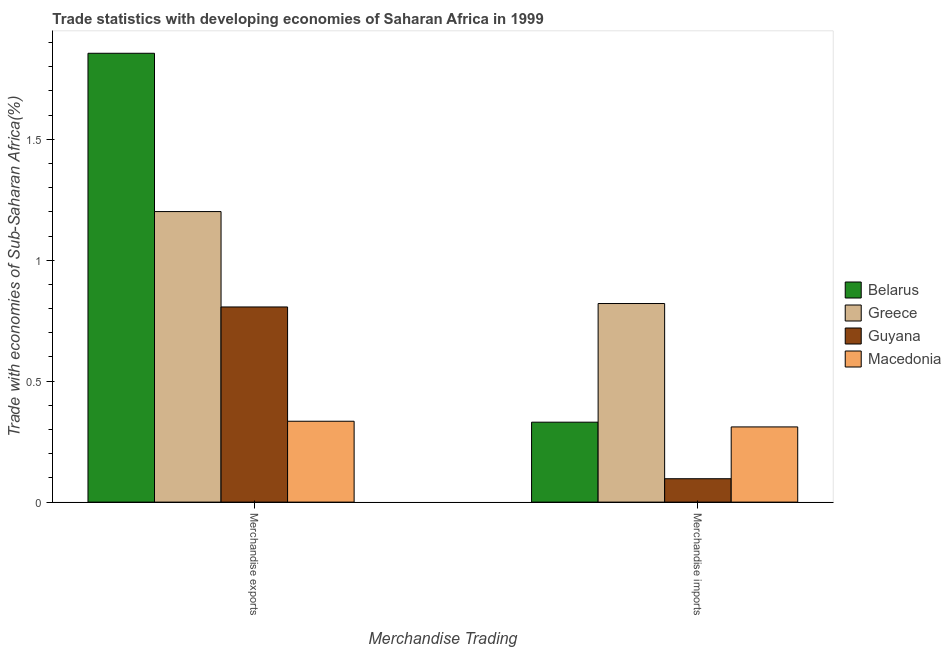How many groups of bars are there?
Your answer should be compact. 2. How many bars are there on the 2nd tick from the left?
Your answer should be very brief. 4. What is the merchandise exports in Belarus?
Offer a terse response. 1.86. Across all countries, what is the maximum merchandise imports?
Provide a short and direct response. 0.82. Across all countries, what is the minimum merchandise exports?
Your answer should be compact. 0.33. In which country was the merchandise exports maximum?
Provide a succinct answer. Belarus. In which country was the merchandise imports minimum?
Provide a short and direct response. Guyana. What is the total merchandise imports in the graph?
Your answer should be very brief. 1.56. What is the difference between the merchandise exports in Macedonia and that in Guyana?
Offer a terse response. -0.47. What is the difference between the merchandise imports in Guyana and the merchandise exports in Greece?
Provide a succinct answer. -1.1. What is the average merchandise imports per country?
Your answer should be very brief. 0.39. What is the difference between the merchandise imports and merchandise exports in Guyana?
Provide a short and direct response. -0.71. What is the ratio of the merchandise exports in Belarus to that in Macedonia?
Provide a succinct answer. 5.55. What does the 2nd bar from the left in Merchandise exports represents?
Your answer should be compact. Greece. What does the 1st bar from the right in Merchandise imports represents?
Make the answer very short. Macedonia. How many countries are there in the graph?
Give a very brief answer. 4. What is the difference between two consecutive major ticks on the Y-axis?
Ensure brevity in your answer.  0.5. Are the values on the major ticks of Y-axis written in scientific E-notation?
Your response must be concise. No. Does the graph contain any zero values?
Provide a short and direct response. No. How many legend labels are there?
Make the answer very short. 4. What is the title of the graph?
Give a very brief answer. Trade statistics with developing economies of Saharan Africa in 1999. Does "Nigeria" appear as one of the legend labels in the graph?
Ensure brevity in your answer.  No. What is the label or title of the X-axis?
Keep it short and to the point. Merchandise Trading. What is the label or title of the Y-axis?
Give a very brief answer. Trade with economies of Sub-Saharan Africa(%). What is the Trade with economies of Sub-Saharan Africa(%) of Belarus in Merchandise exports?
Your response must be concise. 1.86. What is the Trade with economies of Sub-Saharan Africa(%) in Greece in Merchandise exports?
Provide a short and direct response. 1.2. What is the Trade with economies of Sub-Saharan Africa(%) in Guyana in Merchandise exports?
Offer a very short reply. 0.81. What is the Trade with economies of Sub-Saharan Africa(%) of Macedonia in Merchandise exports?
Offer a very short reply. 0.33. What is the Trade with economies of Sub-Saharan Africa(%) of Belarus in Merchandise imports?
Keep it short and to the point. 0.33. What is the Trade with economies of Sub-Saharan Africa(%) in Greece in Merchandise imports?
Make the answer very short. 0.82. What is the Trade with economies of Sub-Saharan Africa(%) of Guyana in Merchandise imports?
Your answer should be compact. 0.1. What is the Trade with economies of Sub-Saharan Africa(%) of Macedonia in Merchandise imports?
Provide a short and direct response. 0.31. Across all Merchandise Trading, what is the maximum Trade with economies of Sub-Saharan Africa(%) in Belarus?
Make the answer very short. 1.86. Across all Merchandise Trading, what is the maximum Trade with economies of Sub-Saharan Africa(%) in Greece?
Offer a very short reply. 1.2. Across all Merchandise Trading, what is the maximum Trade with economies of Sub-Saharan Africa(%) in Guyana?
Provide a succinct answer. 0.81. Across all Merchandise Trading, what is the maximum Trade with economies of Sub-Saharan Africa(%) in Macedonia?
Provide a succinct answer. 0.33. Across all Merchandise Trading, what is the minimum Trade with economies of Sub-Saharan Africa(%) in Belarus?
Keep it short and to the point. 0.33. Across all Merchandise Trading, what is the minimum Trade with economies of Sub-Saharan Africa(%) of Greece?
Make the answer very short. 0.82. Across all Merchandise Trading, what is the minimum Trade with economies of Sub-Saharan Africa(%) of Guyana?
Your response must be concise. 0.1. Across all Merchandise Trading, what is the minimum Trade with economies of Sub-Saharan Africa(%) of Macedonia?
Your response must be concise. 0.31. What is the total Trade with economies of Sub-Saharan Africa(%) in Belarus in the graph?
Ensure brevity in your answer.  2.19. What is the total Trade with economies of Sub-Saharan Africa(%) in Greece in the graph?
Your response must be concise. 2.02. What is the total Trade with economies of Sub-Saharan Africa(%) of Guyana in the graph?
Make the answer very short. 0.9. What is the total Trade with economies of Sub-Saharan Africa(%) in Macedonia in the graph?
Provide a succinct answer. 0.65. What is the difference between the Trade with economies of Sub-Saharan Africa(%) in Belarus in Merchandise exports and that in Merchandise imports?
Give a very brief answer. 1.53. What is the difference between the Trade with economies of Sub-Saharan Africa(%) in Greece in Merchandise exports and that in Merchandise imports?
Your answer should be very brief. 0.38. What is the difference between the Trade with economies of Sub-Saharan Africa(%) of Guyana in Merchandise exports and that in Merchandise imports?
Your answer should be very brief. 0.71. What is the difference between the Trade with economies of Sub-Saharan Africa(%) in Macedonia in Merchandise exports and that in Merchandise imports?
Provide a short and direct response. 0.02. What is the difference between the Trade with economies of Sub-Saharan Africa(%) of Belarus in Merchandise exports and the Trade with economies of Sub-Saharan Africa(%) of Greece in Merchandise imports?
Offer a very short reply. 1.03. What is the difference between the Trade with economies of Sub-Saharan Africa(%) of Belarus in Merchandise exports and the Trade with economies of Sub-Saharan Africa(%) of Guyana in Merchandise imports?
Ensure brevity in your answer.  1.76. What is the difference between the Trade with economies of Sub-Saharan Africa(%) in Belarus in Merchandise exports and the Trade with economies of Sub-Saharan Africa(%) in Macedonia in Merchandise imports?
Your answer should be compact. 1.54. What is the difference between the Trade with economies of Sub-Saharan Africa(%) of Greece in Merchandise exports and the Trade with economies of Sub-Saharan Africa(%) of Guyana in Merchandise imports?
Offer a terse response. 1.1. What is the difference between the Trade with economies of Sub-Saharan Africa(%) of Greece in Merchandise exports and the Trade with economies of Sub-Saharan Africa(%) of Macedonia in Merchandise imports?
Provide a short and direct response. 0.89. What is the difference between the Trade with economies of Sub-Saharan Africa(%) of Guyana in Merchandise exports and the Trade with economies of Sub-Saharan Africa(%) of Macedonia in Merchandise imports?
Your response must be concise. 0.5. What is the average Trade with economies of Sub-Saharan Africa(%) of Belarus per Merchandise Trading?
Make the answer very short. 1.09. What is the average Trade with economies of Sub-Saharan Africa(%) in Greece per Merchandise Trading?
Offer a terse response. 1.01. What is the average Trade with economies of Sub-Saharan Africa(%) of Guyana per Merchandise Trading?
Your response must be concise. 0.45. What is the average Trade with economies of Sub-Saharan Africa(%) of Macedonia per Merchandise Trading?
Keep it short and to the point. 0.32. What is the difference between the Trade with economies of Sub-Saharan Africa(%) in Belarus and Trade with economies of Sub-Saharan Africa(%) in Greece in Merchandise exports?
Provide a short and direct response. 0.65. What is the difference between the Trade with economies of Sub-Saharan Africa(%) of Belarus and Trade with economies of Sub-Saharan Africa(%) of Guyana in Merchandise exports?
Keep it short and to the point. 1.05. What is the difference between the Trade with economies of Sub-Saharan Africa(%) of Belarus and Trade with economies of Sub-Saharan Africa(%) of Macedonia in Merchandise exports?
Provide a short and direct response. 1.52. What is the difference between the Trade with economies of Sub-Saharan Africa(%) in Greece and Trade with economies of Sub-Saharan Africa(%) in Guyana in Merchandise exports?
Your answer should be very brief. 0.39. What is the difference between the Trade with economies of Sub-Saharan Africa(%) in Greece and Trade with economies of Sub-Saharan Africa(%) in Macedonia in Merchandise exports?
Ensure brevity in your answer.  0.87. What is the difference between the Trade with economies of Sub-Saharan Africa(%) in Guyana and Trade with economies of Sub-Saharan Africa(%) in Macedonia in Merchandise exports?
Your answer should be very brief. 0.47. What is the difference between the Trade with economies of Sub-Saharan Africa(%) of Belarus and Trade with economies of Sub-Saharan Africa(%) of Greece in Merchandise imports?
Provide a succinct answer. -0.49. What is the difference between the Trade with economies of Sub-Saharan Africa(%) of Belarus and Trade with economies of Sub-Saharan Africa(%) of Guyana in Merchandise imports?
Your answer should be compact. 0.23. What is the difference between the Trade with economies of Sub-Saharan Africa(%) in Belarus and Trade with economies of Sub-Saharan Africa(%) in Macedonia in Merchandise imports?
Offer a terse response. 0.02. What is the difference between the Trade with economies of Sub-Saharan Africa(%) of Greece and Trade with economies of Sub-Saharan Africa(%) of Guyana in Merchandise imports?
Keep it short and to the point. 0.72. What is the difference between the Trade with economies of Sub-Saharan Africa(%) of Greece and Trade with economies of Sub-Saharan Africa(%) of Macedonia in Merchandise imports?
Ensure brevity in your answer.  0.51. What is the difference between the Trade with economies of Sub-Saharan Africa(%) of Guyana and Trade with economies of Sub-Saharan Africa(%) of Macedonia in Merchandise imports?
Your response must be concise. -0.21. What is the ratio of the Trade with economies of Sub-Saharan Africa(%) of Belarus in Merchandise exports to that in Merchandise imports?
Give a very brief answer. 5.61. What is the ratio of the Trade with economies of Sub-Saharan Africa(%) of Greece in Merchandise exports to that in Merchandise imports?
Give a very brief answer. 1.46. What is the ratio of the Trade with economies of Sub-Saharan Africa(%) of Guyana in Merchandise exports to that in Merchandise imports?
Provide a short and direct response. 8.34. What is the ratio of the Trade with economies of Sub-Saharan Africa(%) of Macedonia in Merchandise exports to that in Merchandise imports?
Keep it short and to the point. 1.08. What is the difference between the highest and the second highest Trade with economies of Sub-Saharan Africa(%) in Belarus?
Provide a short and direct response. 1.53. What is the difference between the highest and the second highest Trade with economies of Sub-Saharan Africa(%) in Greece?
Offer a terse response. 0.38. What is the difference between the highest and the second highest Trade with economies of Sub-Saharan Africa(%) of Guyana?
Provide a succinct answer. 0.71. What is the difference between the highest and the second highest Trade with economies of Sub-Saharan Africa(%) in Macedonia?
Provide a short and direct response. 0.02. What is the difference between the highest and the lowest Trade with economies of Sub-Saharan Africa(%) of Belarus?
Ensure brevity in your answer.  1.53. What is the difference between the highest and the lowest Trade with economies of Sub-Saharan Africa(%) in Greece?
Offer a terse response. 0.38. What is the difference between the highest and the lowest Trade with economies of Sub-Saharan Africa(%) in Guyana?
Keep it short and to the point. 0.71. What is the difference between the highest and the lowest Trade with economies of Sub-Saharan Africa(%) in Macedonia?
Make the answer very short. 0.02. 